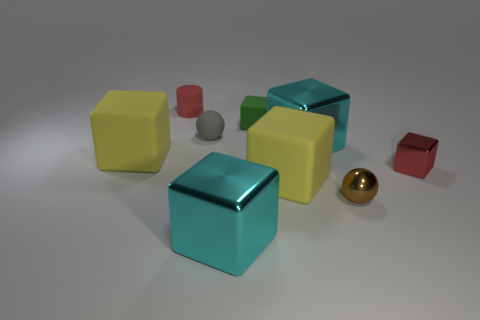Subtract 3 blocks. How many blocks are left? 3 Subtract all red cubes. How many cubes are left? 5 Subtract all large matte cubes. How many cubes are left? 4 Add 1 tiny rubber blocks. How many objects exist? 10 Subtract all brown blocks. Subtract all green cylinders. How many blocks are left? 6 Subtract all balls. How many objects are left? 7 Add 6 small green rubber blocks. How many small green rubber blocks exist? 7 Subtract 0 gray cubes. How many objects are left? 9 Subtract all tiny gray rubber balls. Subtract all cyan cubes. How many objects are left? 6 Add 7 yellow rubber blocks. How many yellow rubber blocks are left? 9 